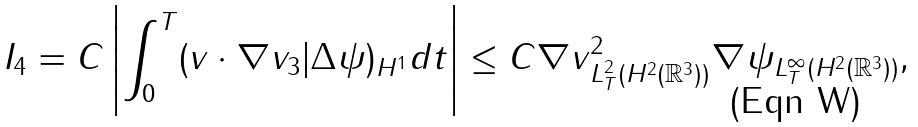Convert formula to latex. <formula><loc_0><loc_0><loc_500><loc_500>I _ { 4 } = C \left | \int ^ { T } _ { 0 } ( v \cdot \nabla v _ { 3 } | \Delta \psi ) _ { H ^ { 1 } } d t \right | \leq C \| \nabla v \| _ { L ^ { 2 } _ { T } ( H ^ { 2 } ( \mathbb { R } ^ { 3 } ) ) } ^ { 2 } \| \nabla \psi \| _ { L ^ { \infty } _ { T } ( H ^ { 2 } ( \mathbb { R } ^ { 3 } ) ) } ,</formula> 